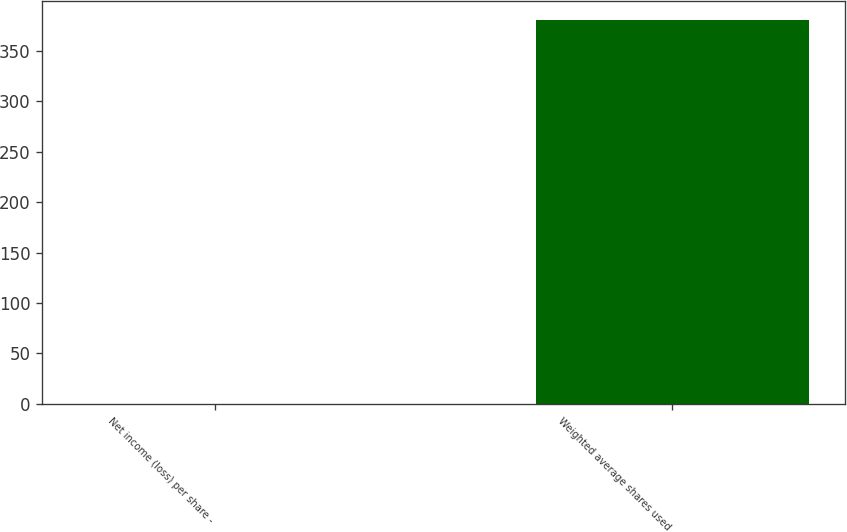Convert chart. <chart><loc_0><loc_0><loc_500><loc_500><bar_chart><fcel>Net income (loss) per share -<fcel>Weighted average shares used<nl><fcel>0.09<fcel>380.59<nl></chart> 